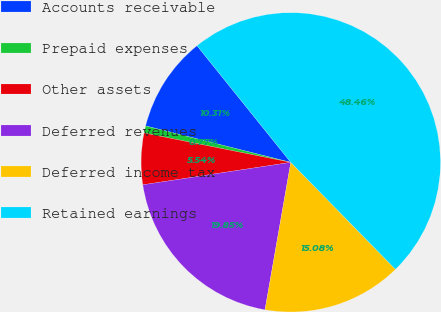<chart> <loc_0><loc_0><loc_500><loc_500><pie_chart><fcel>Accounts receivable<fcel>Prepaid expenses<fcel>Other assets<fcel>Deferred revenues<fcel>Deferred income tax<fcel>Retained earnings<nl><fcel>10.31%<fcel>0.77%<fcel>5.54%<fcel>19.85%<fcel>15.08%<fcel>48.46%<nl></chart> 